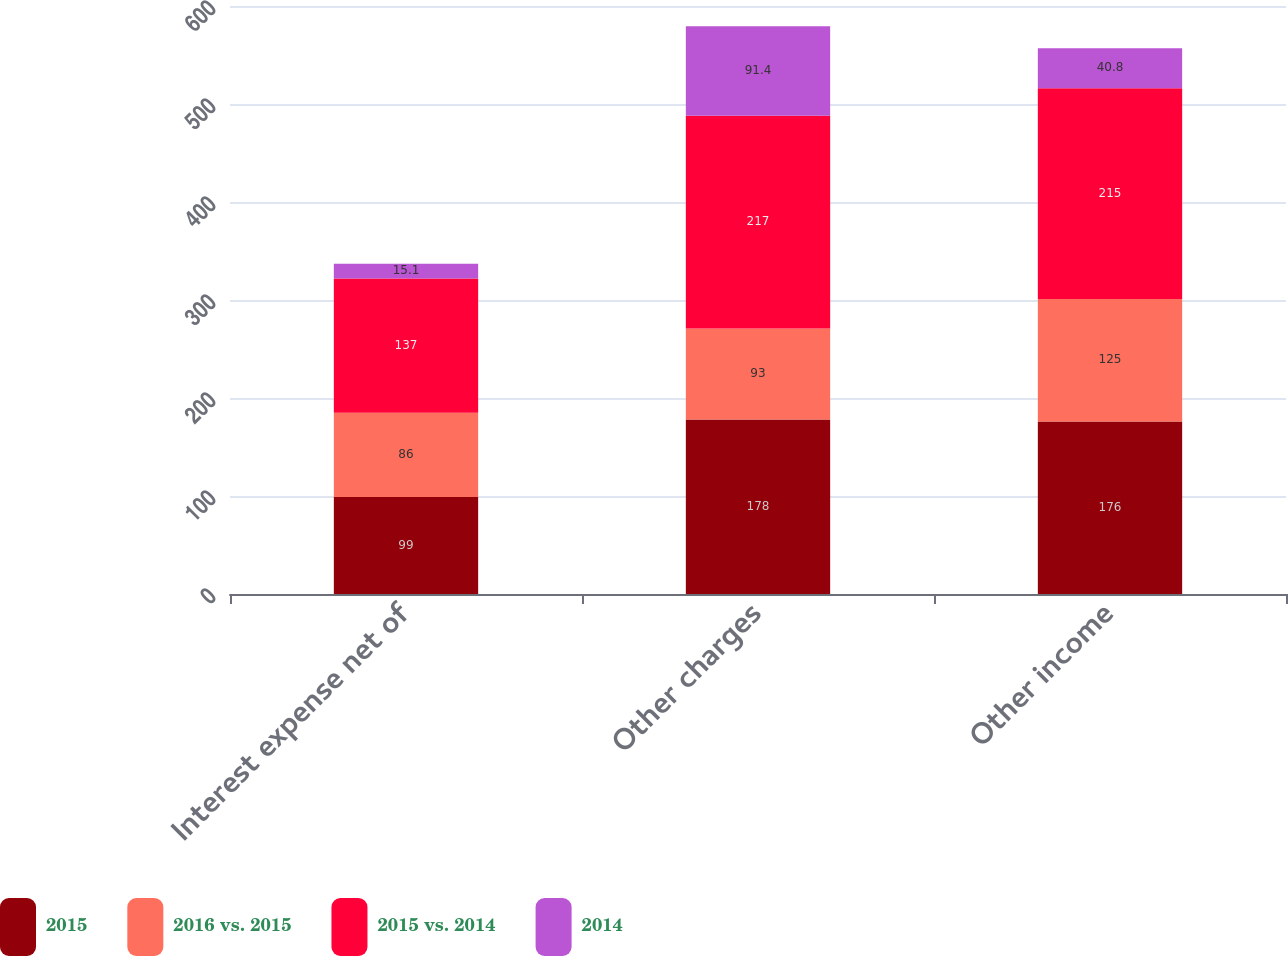Convert chart. <chart><loc_0><loc_0><loc_500><loc_500><stacked_bar_chart><ecel><fcel>Interest expense net of<fcel>Other charges<fcel>Other income<nl><fcel>2015<fcel>99<fcel>178<fcel>176<nl><fcel>2016 vs. 2015<fcel>86<fcel>93<fcel>125<nl><fcel>2015 vs. 2014<fcel>137<fcel>217<fcel>215<nl><fcel>2014<fcel>15.1<fcel>91.4<fcel>40.8<nl></chart> 